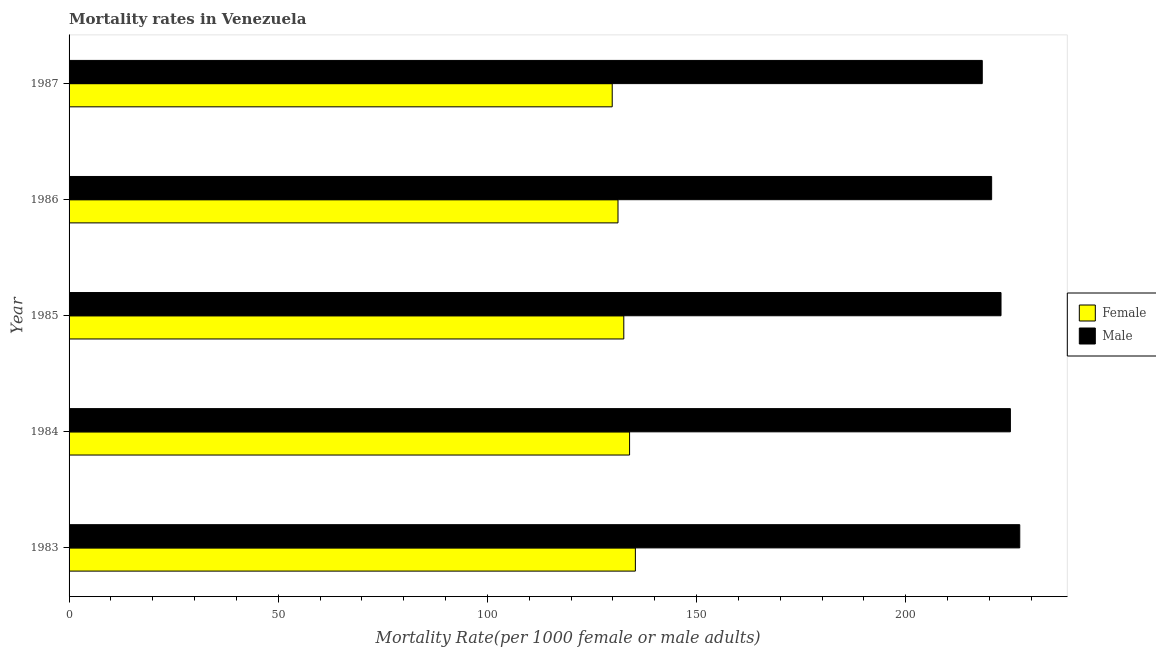Are the number of bars on each tick of the Y-axis equal?
Your response must be concise. Yes. How many bars are there on the 1st tick from the bottom?
Offer a very short reply. 2. What is the male mortality rate in 1984?
Your answer should be very brief. 225. Across all years, what is the maximum female mortality rate?
Your answer should be compact. 135.36. Across all years, what is the minimum female mortality rate?
Keep it short and to the point. 129.82. In which year was the male mortality rate minimum?
Make the answer very short. 1987. What is the total male mortality rate in the graph?
Your answer should be compact. 1113.78. What is the difference between the female mortality rate in 1983 and that in 1984?
Ensure brevity in your answer.  1.38. What is the difference between the female mortality rate in 1985 and the male mortality rate in 1983?
Provide a short and direct response. -94.65. What is the average male mortality rate per year?
Give a very brief answer. 222.76. In the year 1985, what is the difference between the female mortality rate and male mortality rate?
Offer a very short reply. -90.17. What is the ratio of the female mortality rate in 1983 to that in 1987?
Ensure brevity in your answer.  1.04. What is the difference between the highest and the second highest female mortality rate?
Offer a very short reply. 1.38. What is the difference between the highest and the lowest female mortality rate?
Your response must be concise. 5.54. In how many years, is the male mortality rate greater than the average male mortality rate taken over all years?
Give a very brief answer. 3. Is the sum of the female mortality rate in 1984 and 1985 greater than the maximum male mortality rate across all years?
Provide a short and direct response. Yes. What does the 2nd bar from the bottom in 1986 represents?
Your response must be concise. Male. How many bars are there?
Offer a very short reply. 10. How many years are there in the graph?
Give a very brief answer. 5. Are the values on the major ticks of X-axis written in scientific E-notation?
Provide a short and direct response. No. Does the graph contain grids?
Offer a very short reply. No. How many legend labels are there?
Make the answer very short. 2. How are the legend labels stacked?
Provide a short and direct response. Vertical. What is the title of the graph?
Give a very brief answer. Mortality rates in Venezuela. Does "Primary income" appear as one of the legend labels in the graph?
Keep it short and to the point. No. What is the label or title of the X-axis?
Keep it short and to the point. Mortality Rate(per 1000 female or male adults). What is the label or title of the Y-axis?
Keep it short and to the point. Year. What is the Mortality Rate(per 1000 female or male adults) of Female in 1983?
Make the answer very short. 135.36. What is the Mortality Rate(per 1000 female or male adults) in Male in 1983?
Give a very brief answer. 227.24. What is the Mortality Rate(per 1000 female or male adults) of Female in 1984?
Make the answer very short. 133.97. What is the Mortality Rate(per 1000 female or male adults) in Male in 1984?
Ensure brevity in your answer.  225. What is the Mortality Rate(per 1000 female or male adults) in Female in 1985?
Provide a short and direct response. 132.59. What is the Mortality Rate(per 1000 female or male adults) of Male in 1985?
Your response must be concise. 222.76. What is the Mortality Rate(per 1000 female or male adults) in Female in 1986?
Your response must be concise. 131.21. What is the Mortality Rate(per 1000 female or male adults) of Male in 1986?
Keep it short and to the point. 220.51. What is the Mortality Rate(per 1000 female or male adults) in Female in 1987?
Give a very brief answer. 129.82. What is the Mortality Rate(per 1000 female or male adults) in Male in 1987?
Provide a succinct answer. 218.27. Across all years, what is the maximum Mortality Rate(per 1000 female or male adults) in Female?
Provide a succinct answer. 135.36. Across all years, what is the maximum Mortality Rate(per 1000 female or male adults) in Male?
Give a very brief answer. 227.24. Across all years, what is the minimum Mortality Rate(per 1000 female or male adults) in Female?
Make the answer very short. 129.82. Across all years, what is the minimum Mortality Rate(per 1000 female or male adults) of Male?
Give a very brief answer. 218.27. What is the total Mortality Rate(per 1000 female or male adults) in Female in the graph?
Give a very brief answer. 662.96. What is the total Mortality Rate(per 1000 female or male adults) in Male in the graph?
Your response must be concise. 1113.78. What is the difference between the Mortality Rate(per 1000 female or male adults) in Female in 1983 and that in 1984?
Provide a succinct answer. 1.38. What is the difference between the Mortality Rate(per 1000 female or male adults) in Male in 1983 and that in 1984?
Give a very brief answer. 2.24. What is the difference between the Mortality Rate(per 1000 female or male adults) of Female in 1983 and that in 1985?
Provide a succinct answer. 2.77. What is the difference between the Mortality Rate(per 1000 female or male adults) of Male in 1983 and that in 1985?
Provide a short and direct response. 4.48. What is the difference between the Mortality Rate(per 1000 female or male adults) of Female in 1983 and that in 1986?
Give a very brief answer. 4.15. What is the difference between the Mortality Rate(per 1000 female or male adults) of Male in 1983 and that in 1986?
Provide a short and direct response. 6.72. What is the difference between the Mortality Rate(per 1000 female or male adults) of Female in 1983 and that in 1987?
Your answer should be compact. 5.54. What is the difference between the Mortality Rate(per 1000 female or male adults) in Male in 1983 and that in 1987?
Your answer should be very brief. 8.96. What is the difference between the Mortality Rate(per 1000 female or male adults) in Female in 1984 and that in 1985?
Your response must be concise. 1.38. What is the difference between the Mortality Rate(per 1000 female or male adults) of Male in 1984 and that in 1985?
Give a very brief answer. 2.24. What is the difference between the Mortality Rate(per 1000 female or male adults) in Female in 1984 and that in 1986?
Give a very brief answer. 2.77. What is the difference between the Mortality Rate(per 1000 female or male adults) in Male in 1984 and that in 1986?
Ensure brevity in your answer.  4.48. What is the difference between the Mortality Rate(per 1000 female or male adults) of Female in 1984 and that in 1987?
Provide a short and direct response. 4.15. What is the difference between the Mortality Rate(per 1000 female or male adults) in Male in 1984 and that in 1987?
Make the answer very short. 6.72. What is the difference between the Mortality Rate(per 1000 female or male adults) of Female in 1985 and that in 1986?
Your answer should be very brief. 1.38. What is the difference between the Mortality Rate(per 1000 female or male adults) in Male in 1985 and that in 1986?
Offer a very short reply. 2.24. What is the difference between the Mortality Rate(per 1000 female or male adults) in Female in 1985 and that in 1987?
Offer a very short reply. 2.77. What is the difference between the Mortality Rate(per 1000 female or male adults) in Male in 1985 and that in 1987?
Offer a very short reply. 4.48. What is the difference between the Mortality Rate(per 1000 female or male adults) of Female in 1986 and that in 1987?
Your response must be concise. 1.38. What is the difference between the Mortality Rate(per 1000 female or male adults) in Male in 1986 and that in 1987?
Keep it short and to the point. 2.24. What is the difference between the Mortality Rate(per 1000 female or male adults) of Female in 1983 and the Mortality Rate(per 1000 female or male adults) of Male in 1984?
Make the answer very short. -89.64. What is the difference between the Mortality Rate(per 1000 female or male adults) of Female in 1983 and the Mortality Rate(per 1000 female or male adults) of Male in 1985?
Your response must be concise. -87.4. What is the difference between the Mortality Rate(per 1000 female or male adults) in Female in 1983 and the Mortality Rate(per 1000 female or male adults) in Male in 1986?
Your response must be concise. -85.16. What is the difference between the Mortality Rate(per 1000 female or male adults) in Female in 1983 and the Mortality Rate(per 1000 female or male adults) in Male in 1987?
Offer a very short reply. -82.91. What is the difference between the Mortality Rate(per 1000 female or male adults) of Female in 1984 and the Mortality Rate(per 1000 female or male adults) of Male in 1985?
Your response must be concise. -88.78. What is the difference between the Mortality Rate(per 1000 female or male adults) in Female in 1984 and the Mortality Rate(per 1000 female or male adults) in Male in 1986?
Your response must be concise. -86.54. What is the difference between the Mortality Rate(per 1000 female or male adults) of Female in 1984 and the Mortality Rate(per 1000 female or male adults) of Male in 1987?
Make the answer very short. -84.3. What is the difference between the Mortality Rate(per 1000 female or male adults) of Female in 1985 and the Mortality Rate(per 1000 female or male adults) of Male in 1986?
Your response must be concise. -87.92. What is the difference between the Mortality Rate(per 1000 female or male adults) in Female in 1985 and the Mortality Rate(per 1000 female or male adults) in Male in 1987?
Provide a short and direct response. -85.68. What is the difference between the Mortality Rate(per 1000 female or male adults) in Female in 1986 and the Mortality Rate(per 1000 female or male adults) in Male in 1987?
Make the answer very short. -87.07. What is the average Mortality Rate(per 1000 female or male adults) in Female per year?
Offer a terse response. 132.59. What is the average Mortality Rate(per 1000 female or male adults) of Male per year?
Your answer should be compact. 222.76. In the year 1983, what is the difference between the Mortality Rate(per 1000 female or male adults) of Female and Mortality Rate(per 1000 female or male adults) of Male?
Your answer should be compact. -91.88. In the year 1984, what is the difference between the Mortality Rate(per 1000 female or male adults) of Female and Mortality Rate(per 1000 female or male adults) of Male?
Offer a terse response. -91.02. In the year 1985, what is the difference between the Mortality Rate(per 1000 female or male adults) in Female and Mortality Rate(per 1000 female or male adults) in Male?
Give a very brief answer. -90.17. In the year 1986, what is the difference between the Mortality Rate(per 1000 female or male adults) of Female and Mortality Rate(per 1000 female or male adults) of Male?
Offer a very short reply. -89.31. In the year 1987, what is the difference between the Mortality Rate(per 1000 female or male adults) of Female and Mortality Rate(per 1000 female or male adults) of Male?
Your answer should be compact. -88.45. What is the ratio of the Mortality Rate(per 1000 female or male adults) of Female in 1983 to that in 1984?
Your response must be concise. 1.01. What is the ratio of the Mortality Rate(per 1000 female or male adults) of Female in 1983 to that in 1985?
Keep it short and to the point. 1.02. What is the ratio of the Mortality Rate(per 1000 female or male adults) of Male in 1983 to that in 1985?
Make the answer very short. 1.02. What is the ratio of the Mortality Rate(per 1000 female or male adults) in Female in 1983 to that in 1986?
Your answer should be compact. 1.03. What is the ratio of the Mortality Rate(per 1000 female or male adults) in Male in 1983 to that in 1986?
Provide a succinct answer. 1.03. What is the ratio of the Mortality Rate(per 1000 female or male adults) of Female in 1983 to that in 1987?
Provide a short and direct response. 1.04. What is the ratio of the Mortality Rate(per 1000 female or male adults) of Male in 1983 to that in 1987?
Keep it short and to the point. 1.04. What is the ratio of the Mortality Rate(per 1000 female or male adults) of Female in 1984 to that in 1985?
Ensure brevity in your answer.  1.01. What is the ratio of the Mortality Rate(per 1000 female or male adults) in Female in 1984 to that in 1986?
Your answer should be compact. 1.02. What is the ratio of the Mortality Rate(per 1000 female or male adults) in Male in 1984 to that in 1986?
Your response must be concise. 1.02. What is the ratio of the Mortality Rate(per 1000 female or male adults) of Female in 1984 to that in 1987?
Give a very brief answer. 1.03. What is the ratio of the Mortality Rate(per 1000 female or male adults) in Male in 1984 to that in 1987?
Your response must be concise. 1.03. What is the ratio of the Mortality Rate(per 1000 female or male adults) of Female in 1985 to that in 1986?
Your answer should be very brief. 1.01. What is the ratio of the Mortality Rate(per 1000 female or male adults) of Male in 1985 to that in 1986?
Make the answer very short. 1.01. What is the ratio of the Mortality Rate(per 1000 female or male adults) in Female in 1985 to that in 1987?
Give a very brief answer. 1.02. What is the ratio of the Mortality Rate(per 1000 female or male adults) of Male in 1985 to that in 1987?
Make the answer very short. 1.02. What is the ratio of the Mortality Rate(per 1000 female or male adults) in Female in 1986 to that in 1987?
Keep it short and to the point. 1.01. What is the ratio of the Mortality Rate(per 1000 female or male adults) in Male in 1986 to that in 1987?
Offer a very short reply. 1.01. What is the difference between the highest and the second highest Mortality Rate(per 1000 female or male adults) of Female?
Provide a short and direct response. 1.38. What is the difference between the highest and the second highest Mortality Rate(per 1000 female or male adults) of Male?
Provide a short and direct response. 2.24. What is the difference between the highest and the lowest Mortality Rate(per 1000 female or male adults) of Female?
Make the answer very short. 5.54. What is the difference between the highest and the lowest Mortality Rate(per 1000 female or male adults) in Male?
Provide a short and direct response. 8.96. 